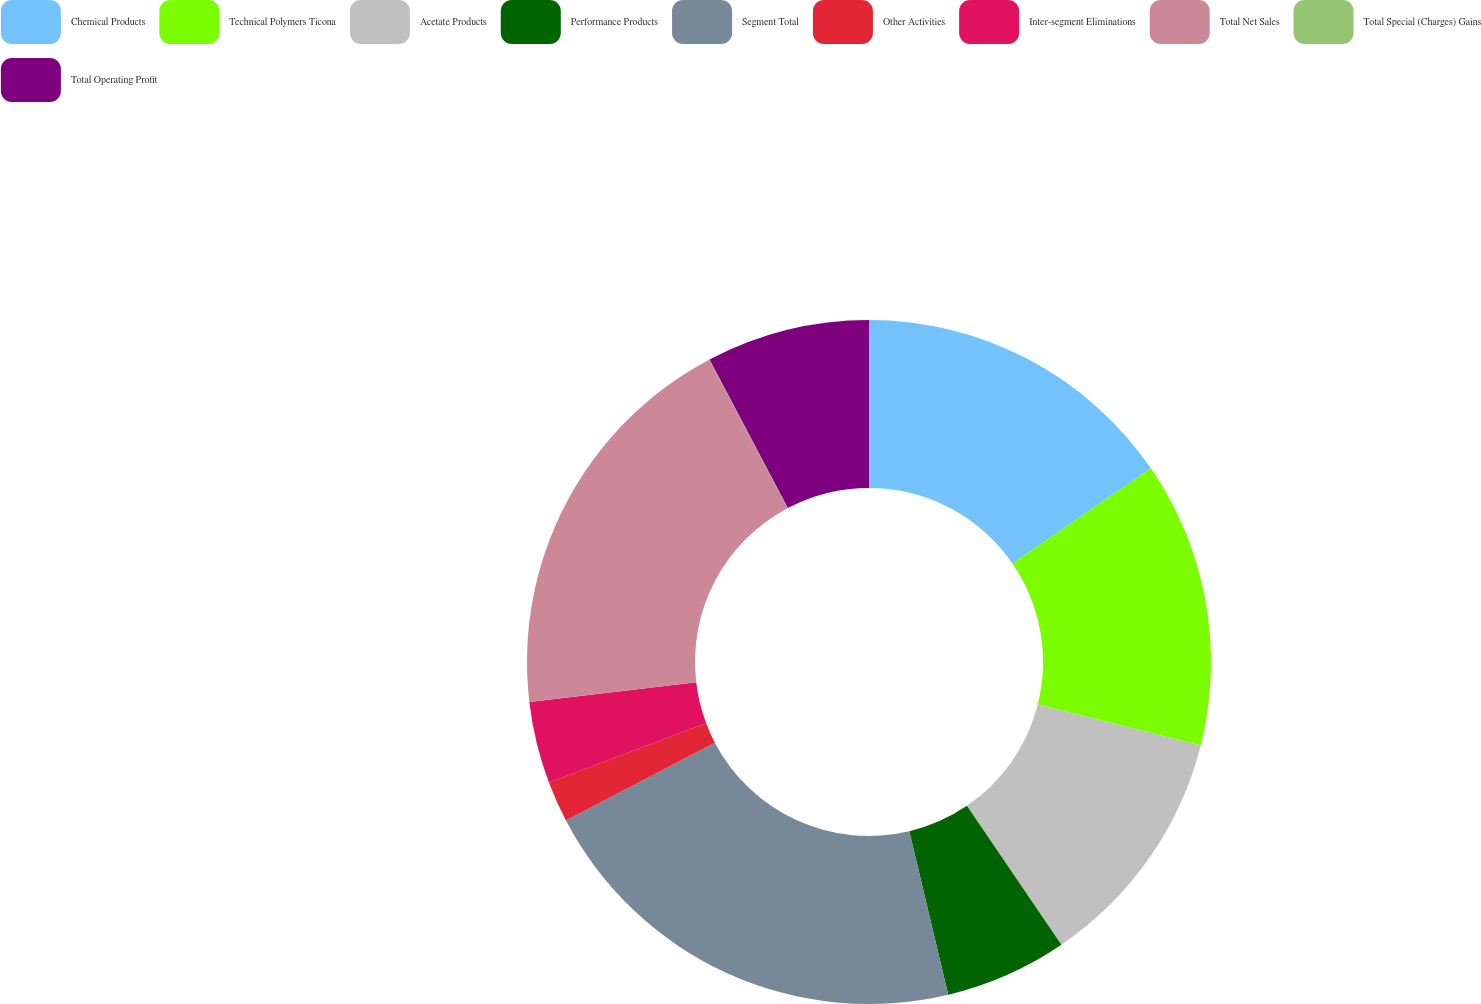<chart> <loc_0><loc_0><loc_500><loc_500><pie_chart><fcel>Chemical Products<fcel>Technical Polymers Ticona<fcel>Acetate Products<fcel>Performance Products<fcel>Segment Total<fcel>Other Activities<fcel>Inter-segment Eliminations<fcel>Total Net Sales<fcel>Total Special (Charges) Gains<fcel>Total Operating Profit<nl><fcel>15.42%<fcel>13.5%<fcel>11.57%<fcel>5.79%<fcel>21.05%<fcel>1.94%<fcel>3.87%<fcel>19.12%<fcel>0.02%<fcel>7.72%<nl></chart> 